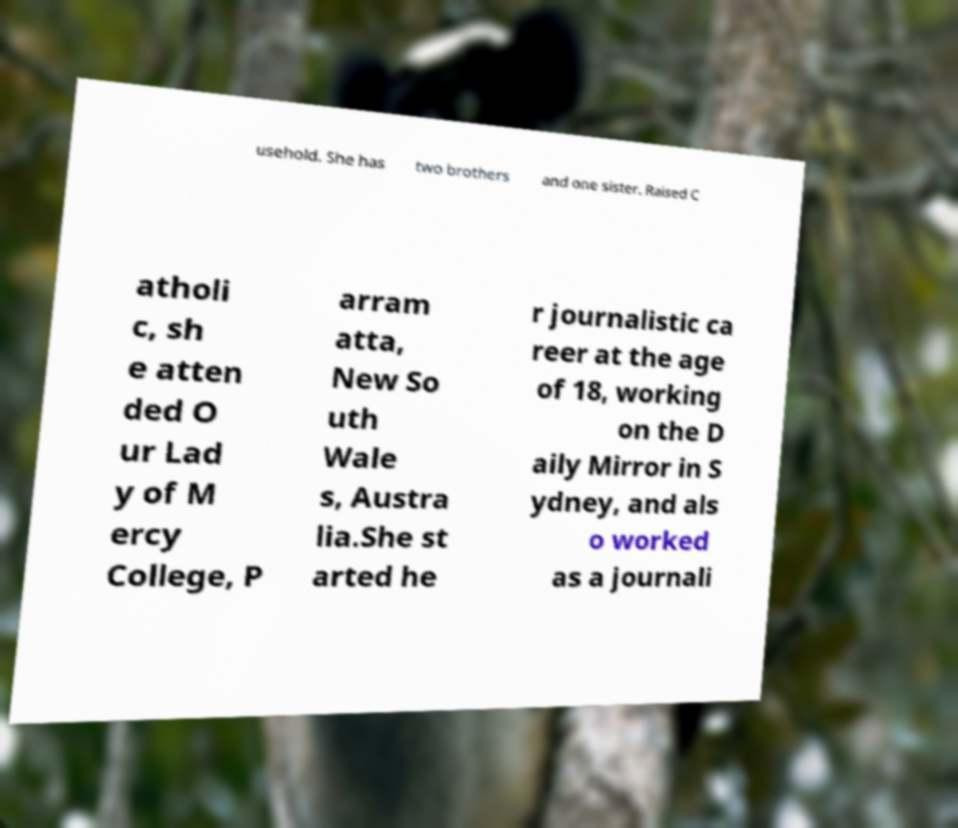Can you read and provide the text displayed in the image?This photo seems to have some interesting text. Can you extract and type it out for me? usehold. She has two brothers and one sister. Raised C atholi c, sh e atten ded O ur Lad y of M ercy College, P arram atta, New So uth Wale s, Austra lia.She st arted he r journalistic ca reer at the age of 18, working on the D aily Mirror in S ydney, and als o worked as a journali 